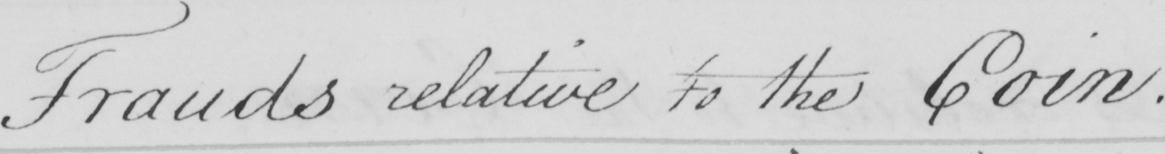What does this handwritten line say? Frauds relative to the Coin . 